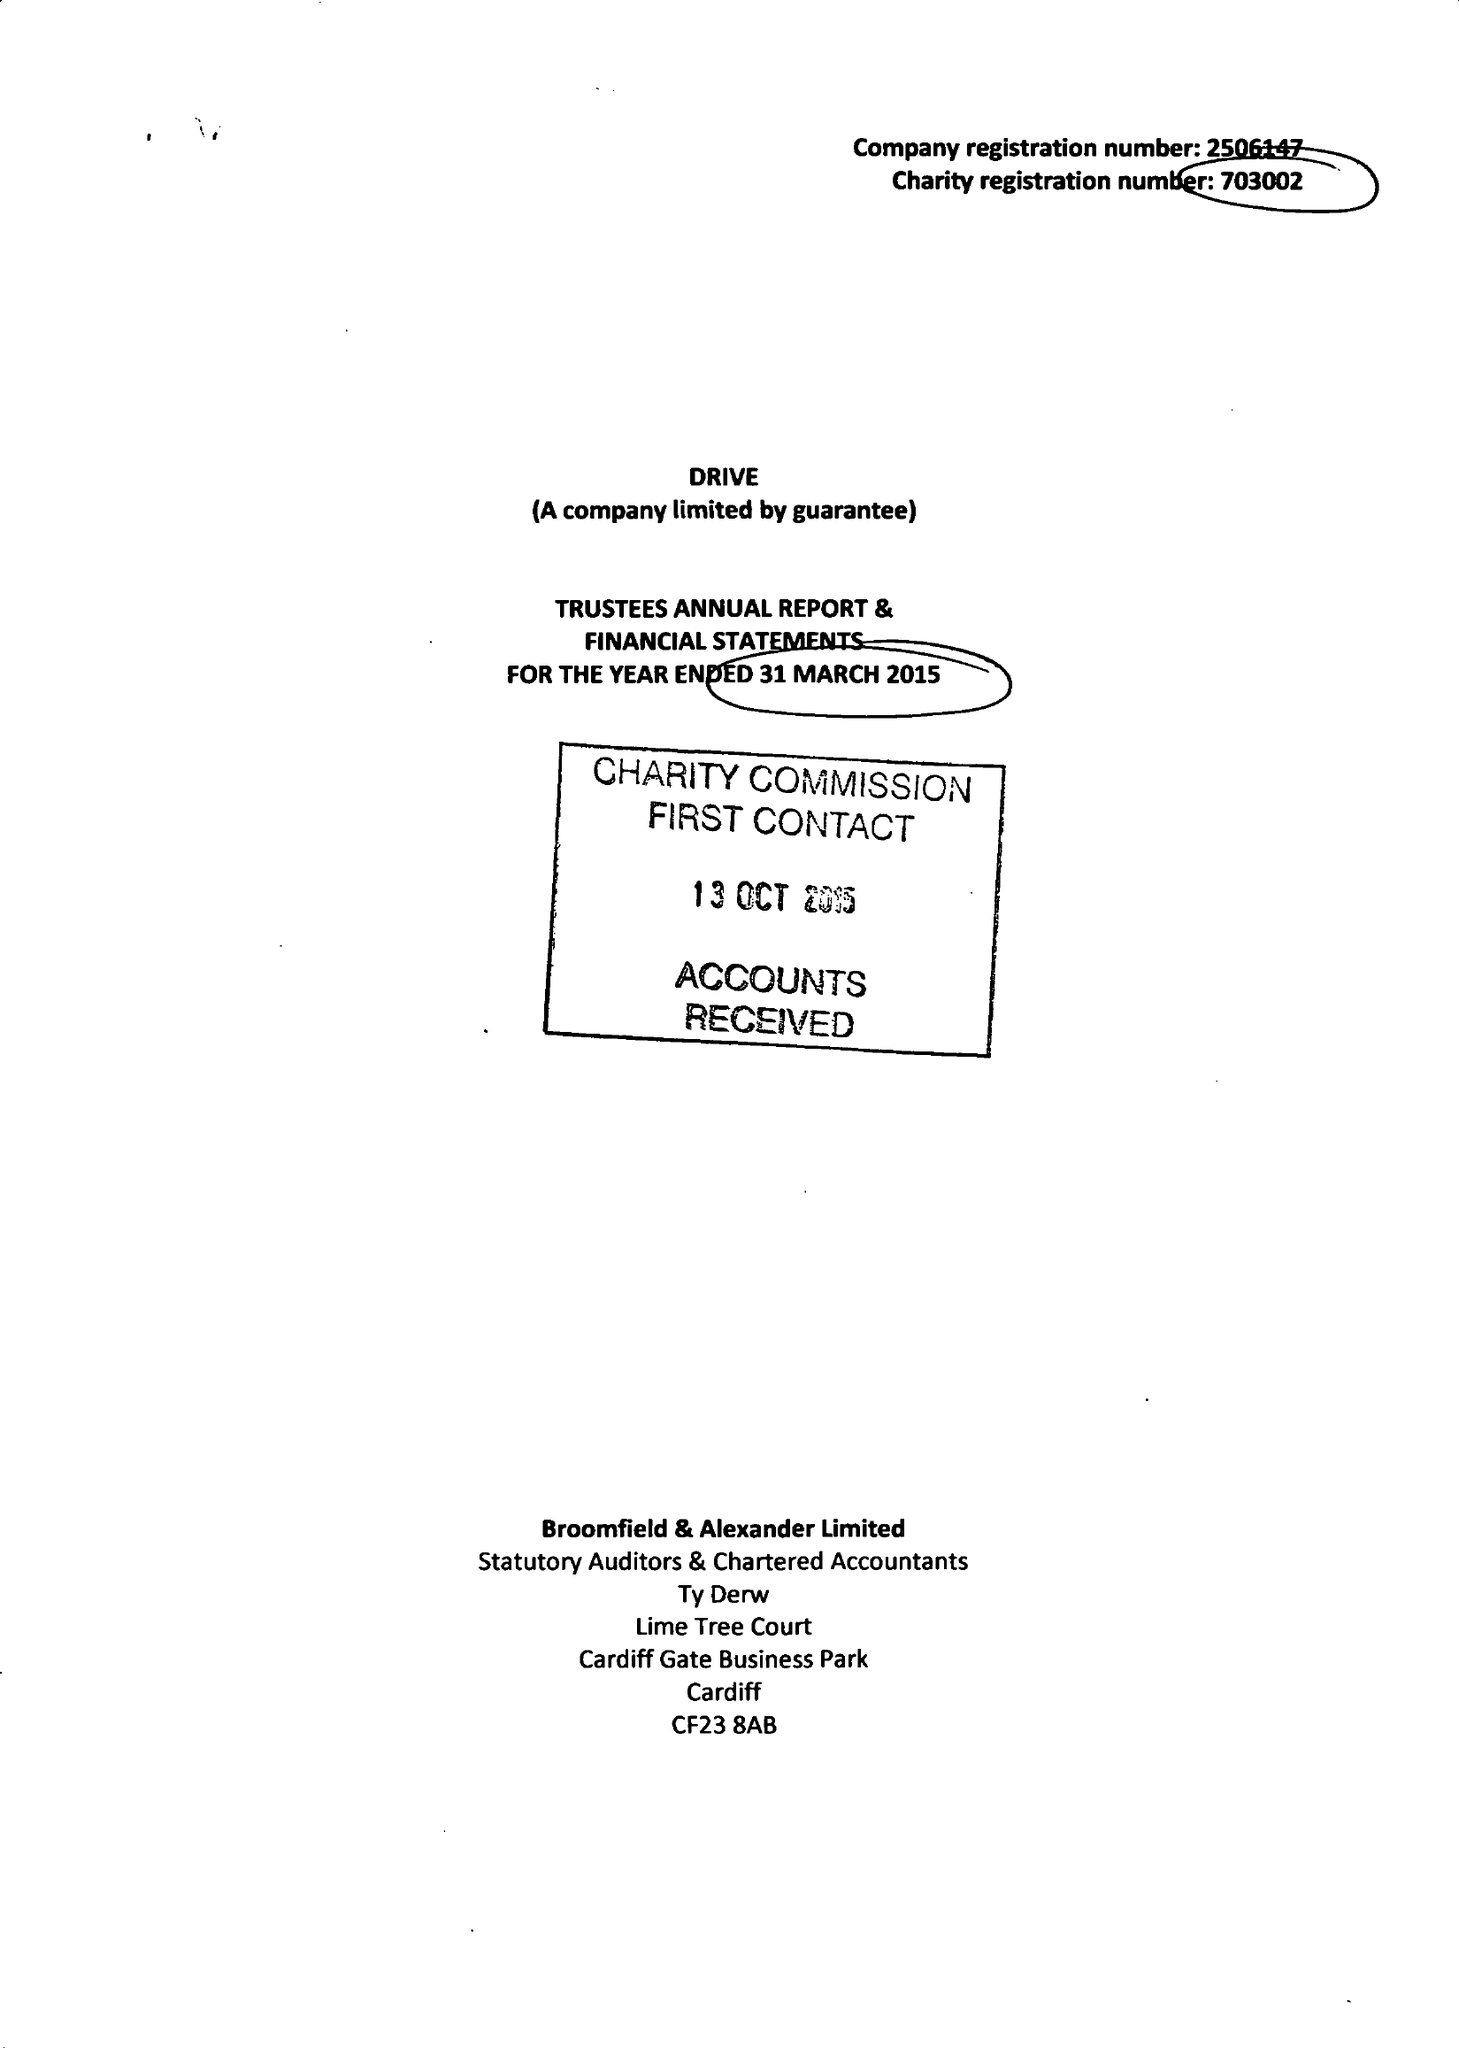What is the value for the spending_annually_in_british_pounds?
Answer the question using a single word or phrase. 11337151.00 